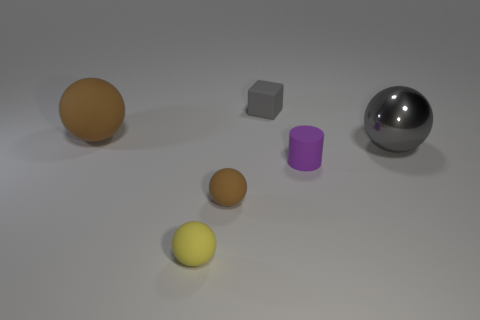The large ball in front of the rubber thing on the left side of the yellow matte object left of the small rubber cylinder is what color?
Make the answer very short. Gray. What color is the small cylinder that is the same material as the cube?
Keep it short and to the point. Purple. Are there any other things that have the same size as the gray block?
Keep it short and to the point. Yes. What number of objects are either tiny things behind the gray ball or gray objects on the left side of the gray metal ball?
Your answer should be compact. 1. Is the size of the sphere in front of the small brown matte sphere the same as the matte ball behind the purple thing?
Your answer should be very brief. No. What is the color of the other tiny thing that is the same shape as the tiny yellow thing?
Your answer should be very brief. Brown. Is there any other thing that has the same shape as the large brown matte object?
Offer a terse response. Yes. Is the number of purple rubber cylinders on the right side of the large gray metallic ball greater than the number of tiny purple rubber objects in front of the purple matte object?
Ensure brevity in your answer.  No. What is the size of the gray thing that is in front of the matte object behind the big sphere left of the tiny yellow thing?
Your response must be concise. Large. Is the small yellow sphere made of the same material as the sphere right of the tiny brown ball?
Ensure brevity in your answer.  No. 